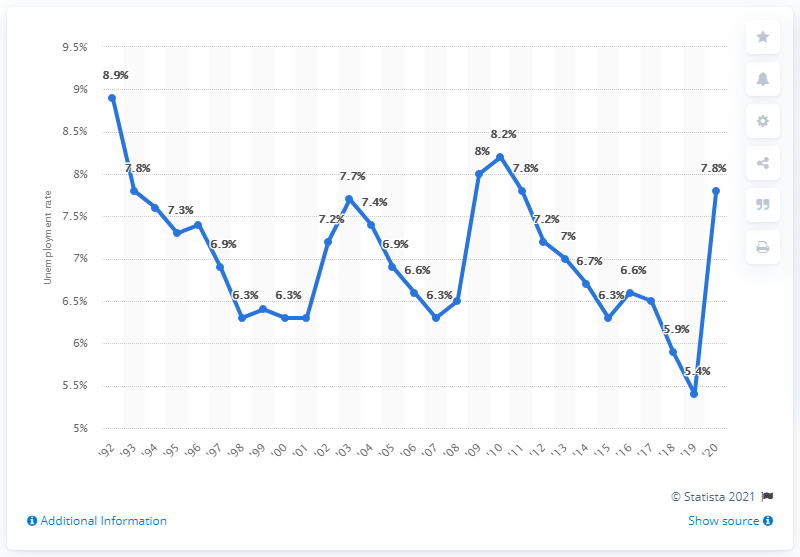Mention a couple of crucial points in this snapshot. In 1992, the highest unemployment rate in Alaska was 8.9%. In 2020, the unemployment rate in Alaska was 7.8%. 